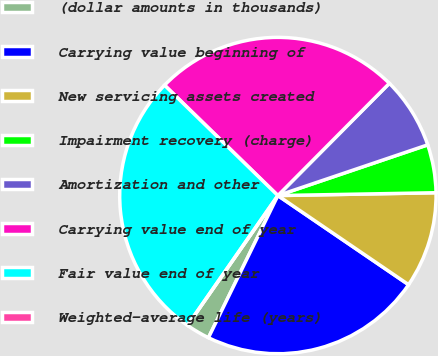Convert chart. <chart><loc_0><loc_0><loc_500><loc_500><pie_chart><fcel>(dollar amounts in thousands)<fcel>Carrying value beginning of<fcel>New servicing assets created<fcel>Impairment recovery (charge)<fcel>Amortization and other<fcel>Carrying value end of year<fcel>Fair value end of year<fcel>Weighted-average life (years)<nl><fcel>2.45%<fcel>22.71%<fcel>9.81%<fcel>4.91%<fcel>7.36%<fcel>25.16%<fcel>27.61%<fcel>0.0%<nl></chart> 